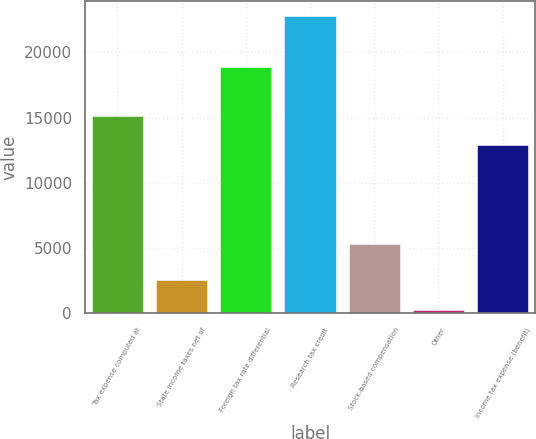<chart> <loc_0><loc_0><loc_500><loc_500><bar_chart><fcel>Tax expense computed at<fcel>State income taxes net of<fcel>Foreign tax rate differential<fcel>Research tax credit<fcel>Stock-based compensation<fcel>Other<fcel>Income tax expense (benefit)<nl><fcel>15160.9<fcel>2534.9<fcel>18875<fcel>22766<fcel>5342<fcel>287<fcel>12913<nl></chart> 